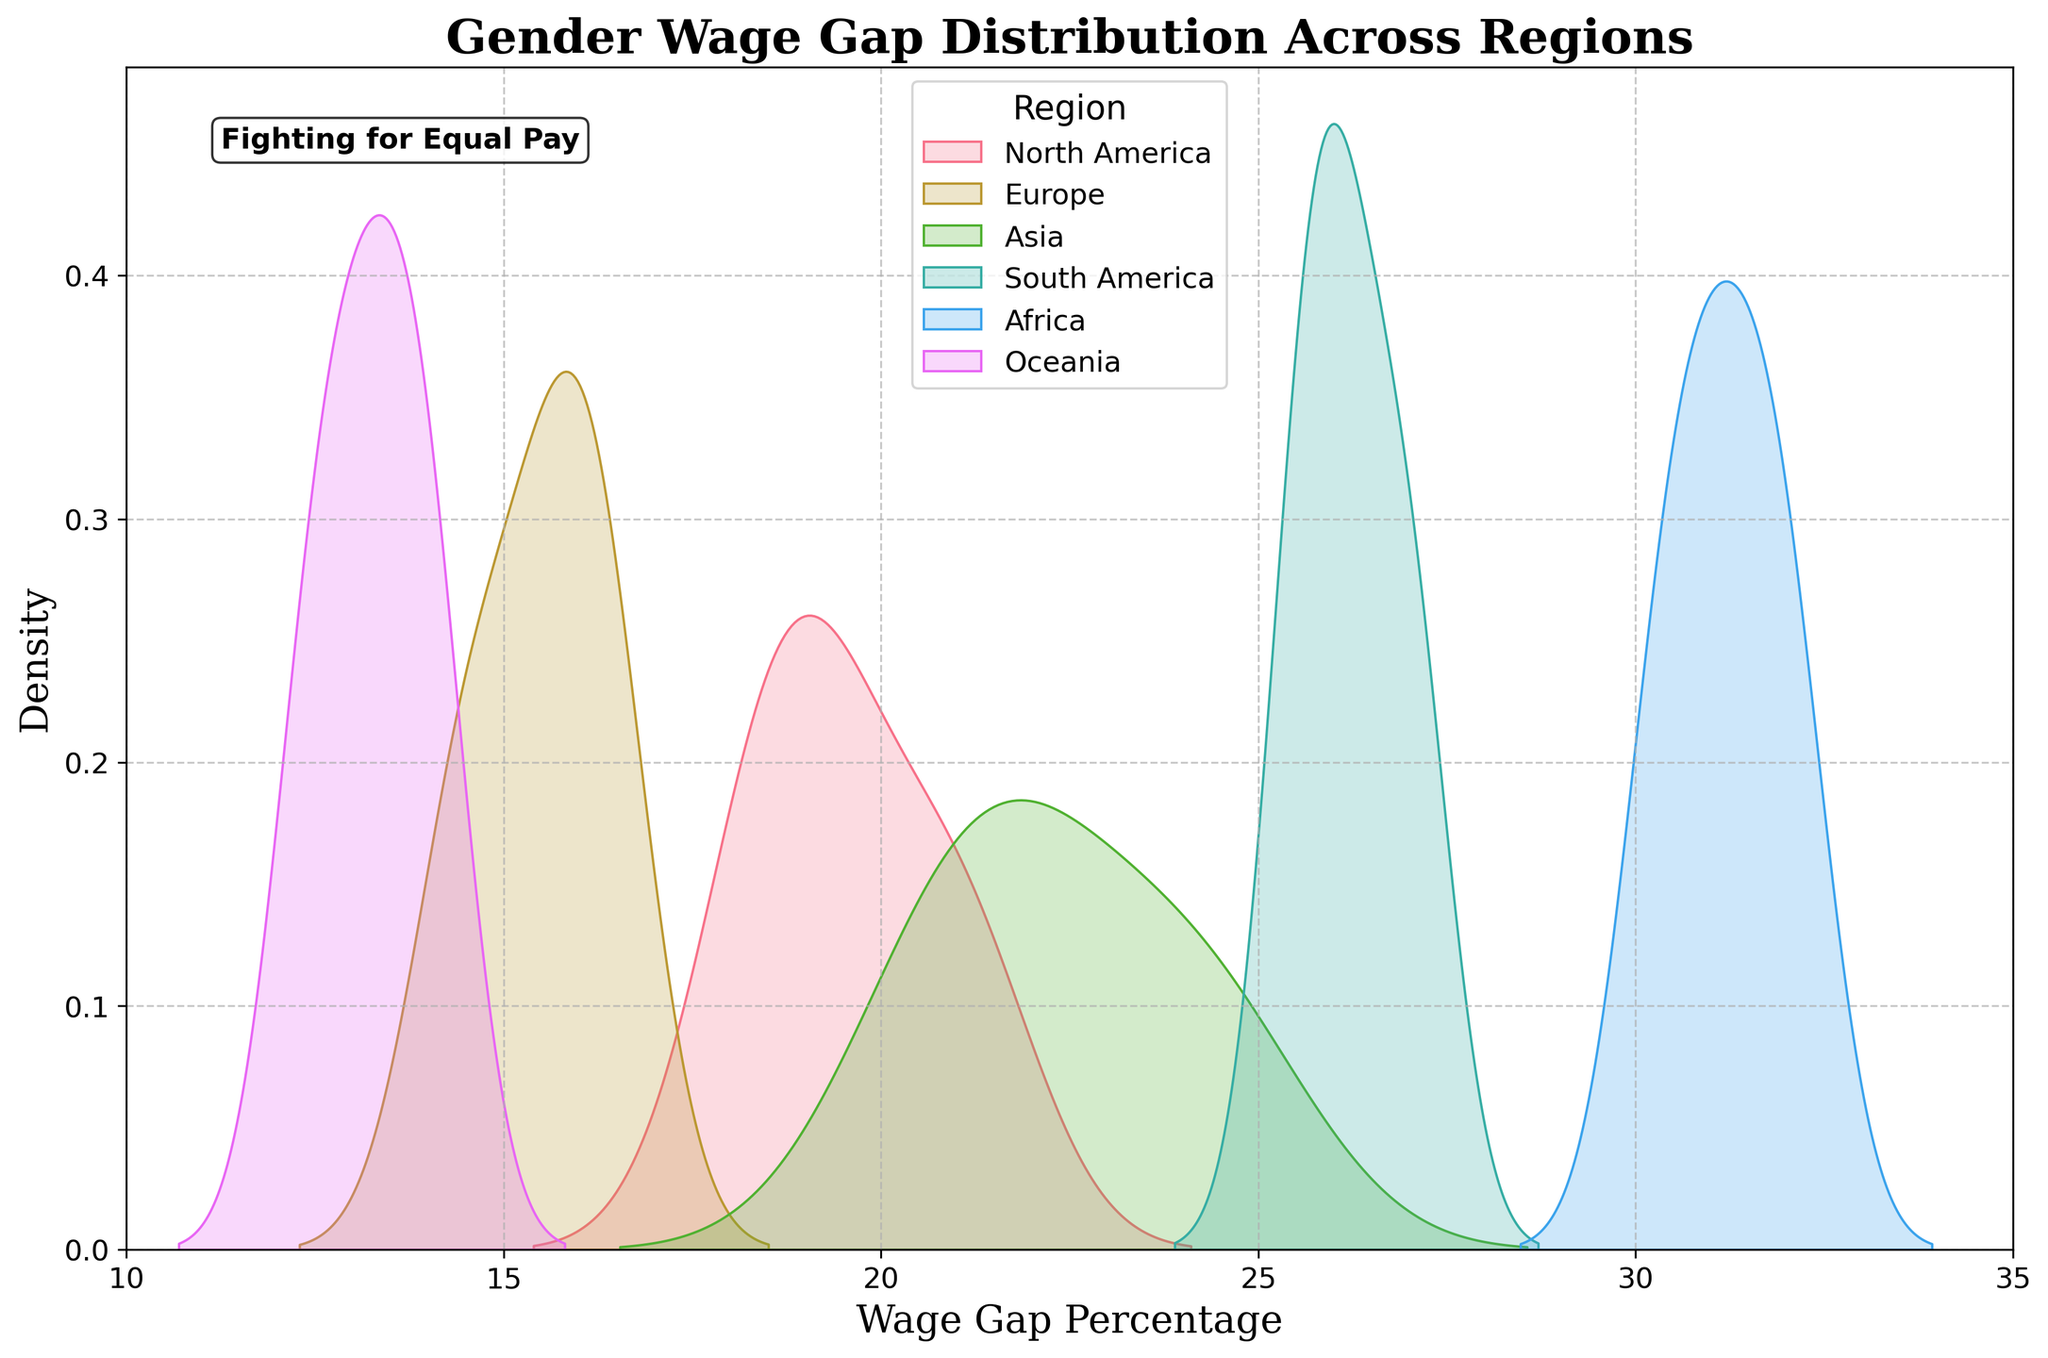what is the title of the plot? The title of the plot is displayed prominently at the top of the figure.
Answer: Gender Wage Gap Distribution Across Regions what do the axes represent? The x-axis represents the Wage Gap Percentage, and the y-axis represents the Density. This is derived from the axis labels.
Answer: Wage Gap Percentage and Density which region has the highest density in the plot? The region with the highest density can be identified by looking at the peak of the density curve.
Answer: Africa within what range does the wage gap percentage in Oceania primarily fall? By observing the density curve for Oceania, we can see where the majority of the data points lie.
Answer: 12.5 to 14 how many regions are represented on the plot? The legend at the bottom right of the plot lists all the regions included.
Answer: 6 which region shows the most considerable wage gap percentage range? By examining the spread of the density curves, the range for each region can be determined.
Answer: Africa compare the wage gap percentage ranges in North America and Europe. To compare ranges, observe the spread of their density curves. North America's range is between 18.5 and 21, while Europe's range is between 14.5 and 16.3.
Answer: North America: 18.5-21, Europe: 14.5-16.3 how does the wage gap percentage in Asia compare to South America? Look at both density curves for Asia and South America and compare their ranges and densities. Asia's wage gap ranges from 20.8 to 24.3, while South America's is between 25.6 and 27.
Answer: Asia: 20.8-24.3, South America: 25.6-27 what message is conveyed through the text annotation on the plot? The text annotation adds context and emphasis to the chart's theme, focusing on the broader message or social context.
Answer: Fighting for Equal Pay 